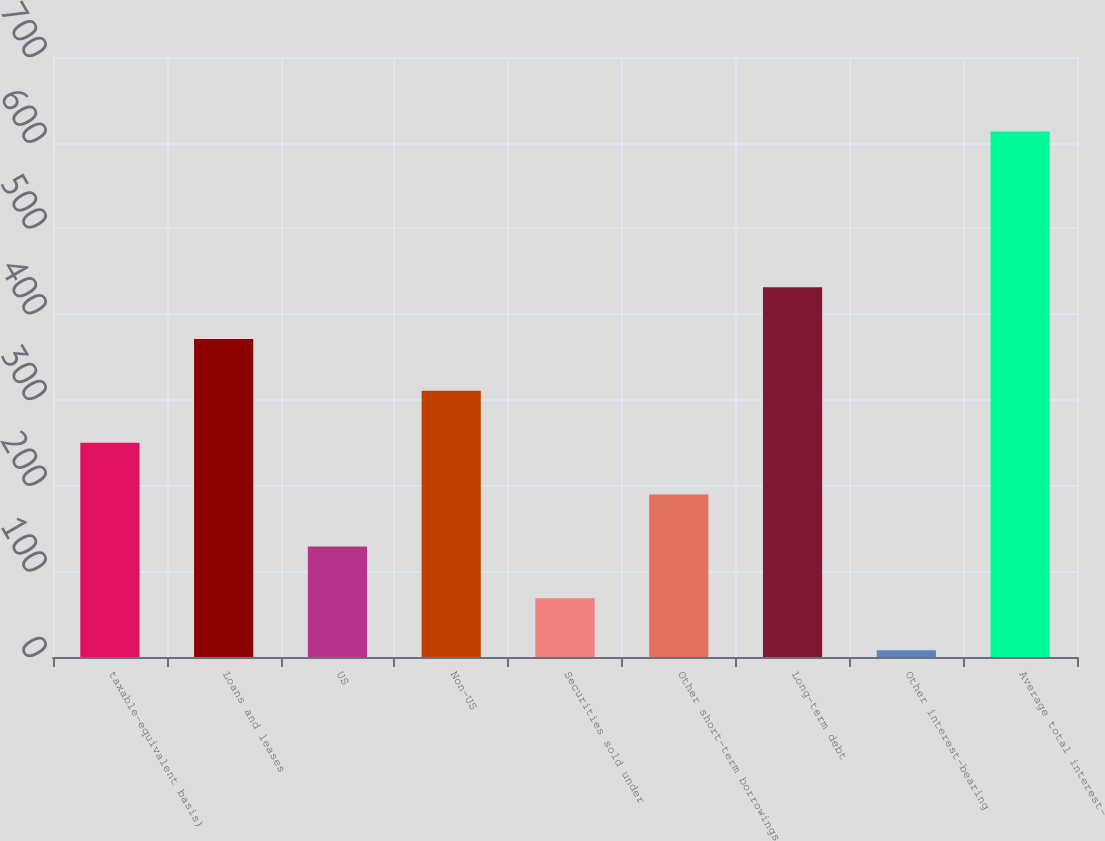<chart> <loc_0><loc_0><loc_500><loc_500><bar_chart><fcel>taxable-equivalent basis)<fcel>Loans and leases<fcel>US<fcel>Non-US<fcel>Securities sold under<fcel>Other short-term borrowings<fcel>Long-term debt<fcel>Other interest-bearing<fcel>Average total interest-<nl><fcel>250<fcel>371<fcel>129<fcel>310.5<fcel>68.5<fcel>189.5<fcel>431.5<fcel>8<fcel>613<nl></chart> 